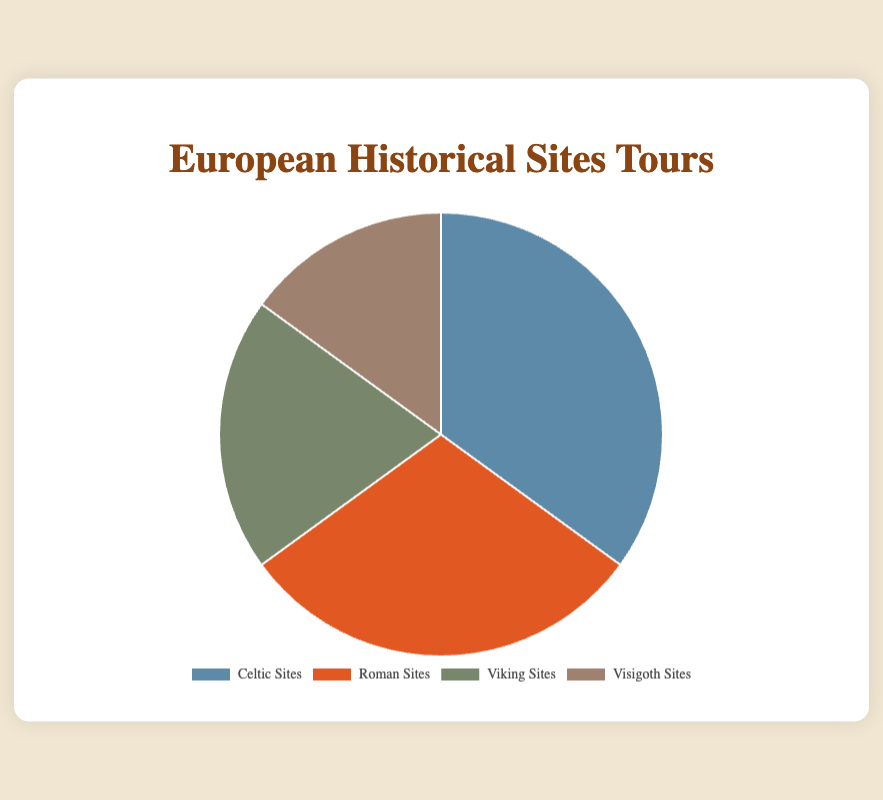What proportion of the tours are dedicated to Celtic Sites? By looking at the pie chart, the segment labeled "Celtic Sites" corresponds to 35%.
Answer: 35% Which tribe sites have the smallest representation? By examining the pie chart, the smallest segment is labeled "Visigoth Sites", corresponding to 15%.
Answer: Visigoth Sites How many percentage points more are dedicated to Celtic Sites compared to Visigoth Sites? Subtract the percentage of Visigoth Sites (15%) from the percentage of Celtic Sites (35%). 35% - 15% = 20%.
Answer: 20% Are Roman Sites tours more or less than Viking Sites tours? Compare the pie chart segments: Roman Sites show 30%, while Viking Sites show 20%. Therefore, Roman Sites tours are more.
Answer: More If you combine the proportion of Viking Sites and Visigoth Sites, what is the total percentage? Add together the percentages of Viking Sites (20%) and Visigoth Sites (15%). 20% + 15% = 35%.
Answer: 35% What is the difference between the largest and smallest proportions of the tour types? Subtract the smallest proportion (Visigoth Sites, 15%) from the largest proportion (Celtic Sites, 35%). 35% - 15% = 20%.
Answer: 20% Which tour types together constitute more than half of the total tours? Add together different combinations of tour types to find the sum that exceeds 50%. Celtic Sites (35%) and Roman Sites (30%) together form 65%, which is more than half.
Answer: Celtic Sites and Roman Sites What percentage of tours is represented by non-Roman Sites? Subtract the Roman Sites proportion (30%) from 100%. 100% - 30% = 70%.
Answer: 70% What color represents Viking Sites tours in the pie chart? By visually identifying the color of the Viking Sites segment in the pie chart, it is the grayish-green segment.
Answer: grayish-green Is the combined percentage of Celtic Sites and Roman Sites greater than 50%? Add the percentages of Celtic Sites (35%) and Roman Sites (30%). 35% + 30% = 65%, which is greater than 50%.
Answer: Yes 